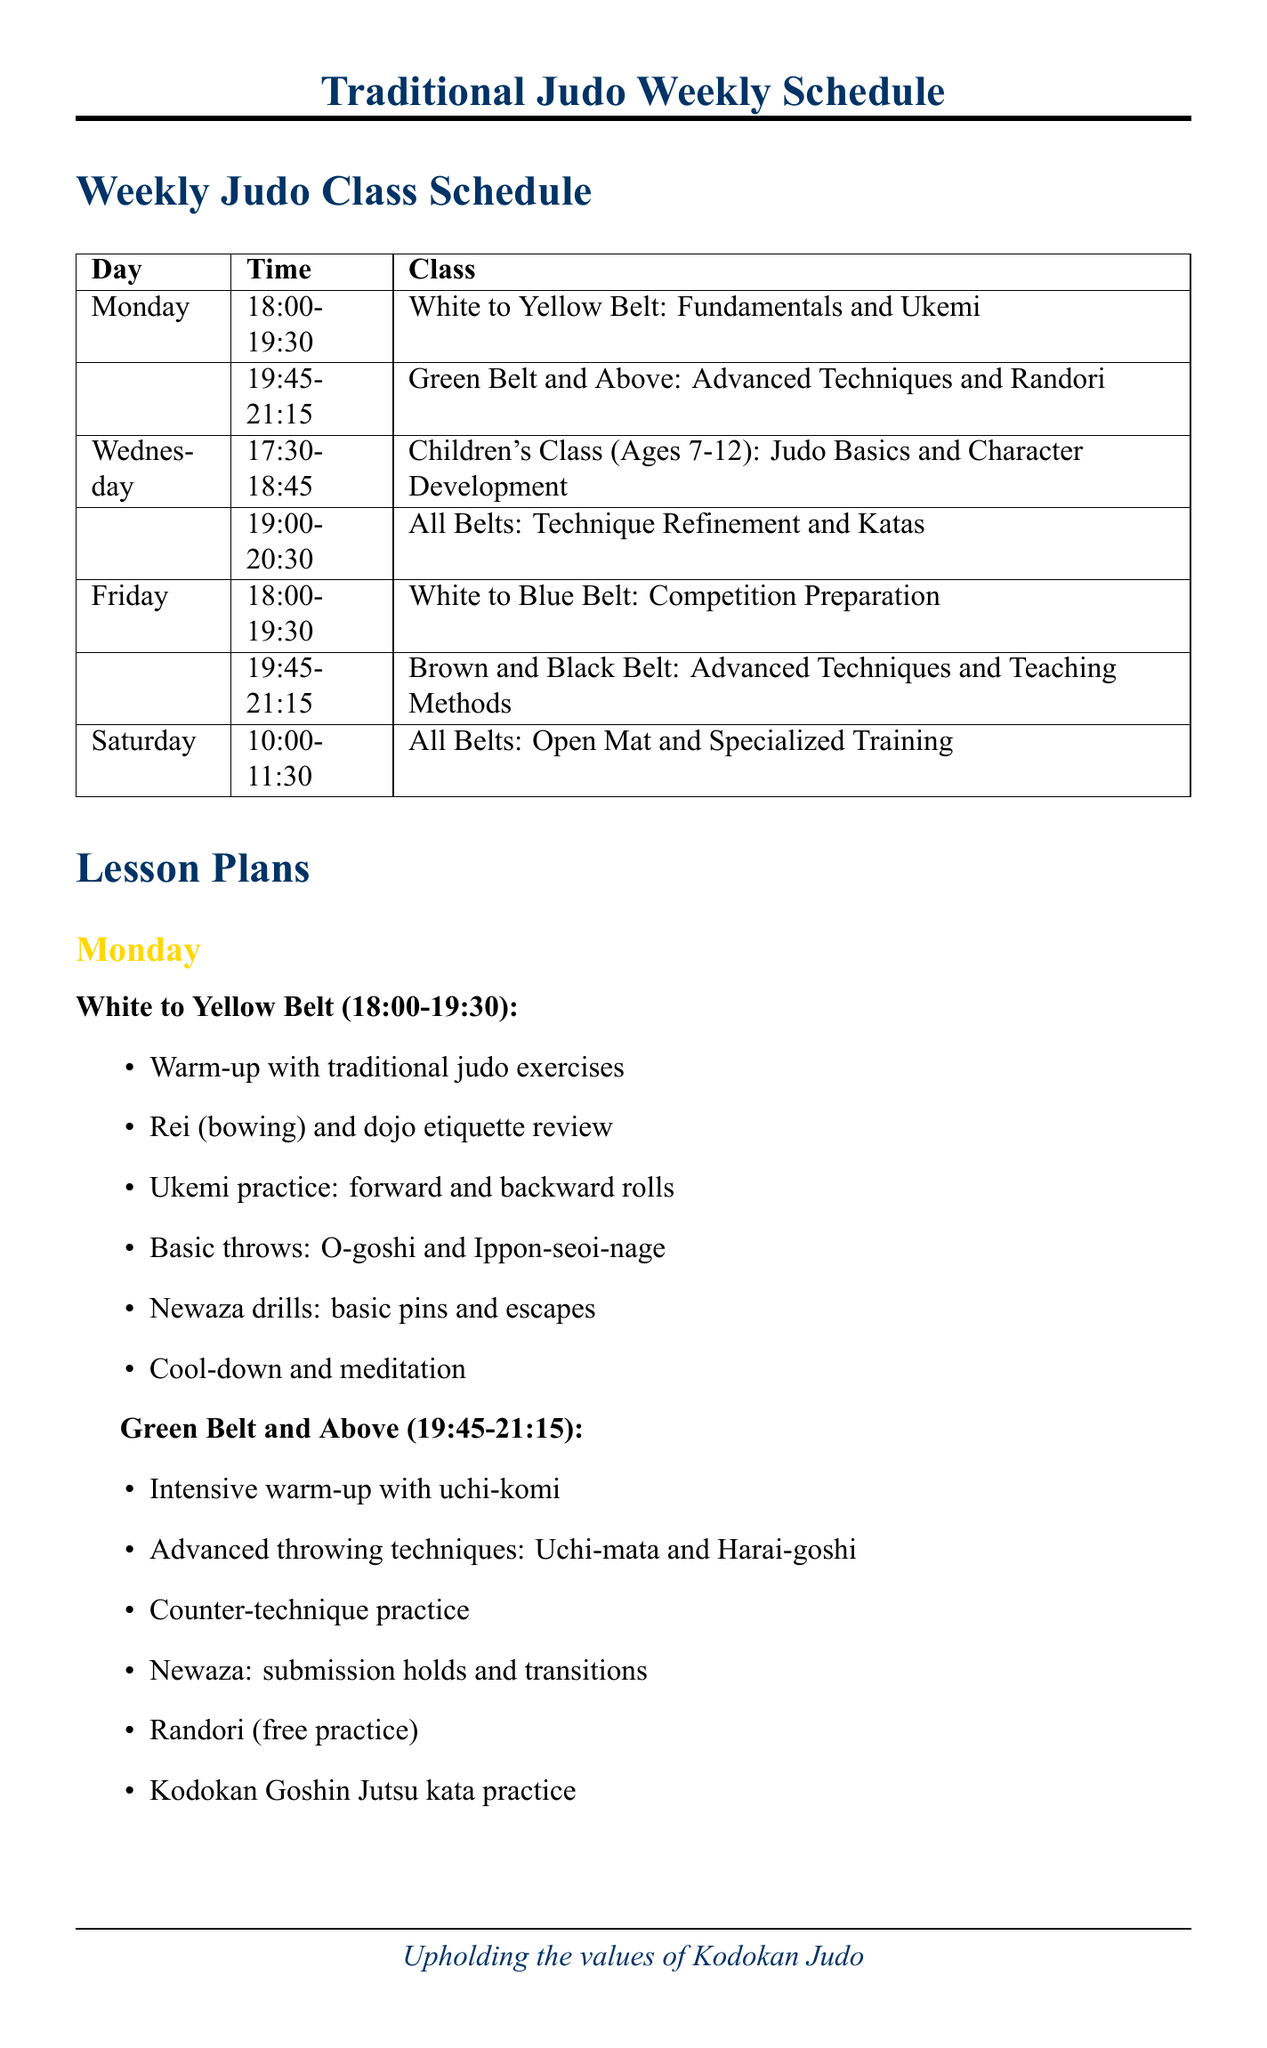What is the time for the White to Yellow Belt class on Monday? The schedule lists the time of the White to Yellow Belt class on Monday as 18:00-19:30.
Answer: 18:00-19:30 What is the focus area for the Friday class for Brown and Black Belt students? The focus area for the Friday class for Brown and Black Belt students, as per the schedule, is Advanced Techniques and Teaching Methods.
Answer: Advanced Techniques and Teaching Methods On which day is the Children's Class held? According to the schedule, the Children's Class occurs on Wednesday.
Answer: Wednesday Which belt level practices Newaza drills on Monday? The level practicing Newaza drills on Monday is White to Yellow Belt.
Answer: White to Yellow Belt How long is the All Belts class on Wednesday? The All Belts class on Wednesday runs from 19:00 to 20:30, which is 1 hour and 30 minutes long.
Answer: 1 hour and 30 minutes What is emphasized during the Saturday class for all belts? The Saturday class for all belts emphasizes Open Mat and Specialized Training.
Answer: Open Mat and Specialized Training How many classes are scheduled on Friday? There are two classes scheduled on Friday, one for White to Blue Belt and another for Brown and Black Belt.
Answer: Two What kind of techniques are practiced during the lesson for Green Belt and Above on Monday? Monday's lesson for Green Belt and Above includes Advanced Throwing Techniques.
Answer: Advanced Throwing Techniques What is discouraged according to the additional notes? The additional notes state that cross-training is discouraged to maintain focus on pure judo.
Answer: Cross-training 